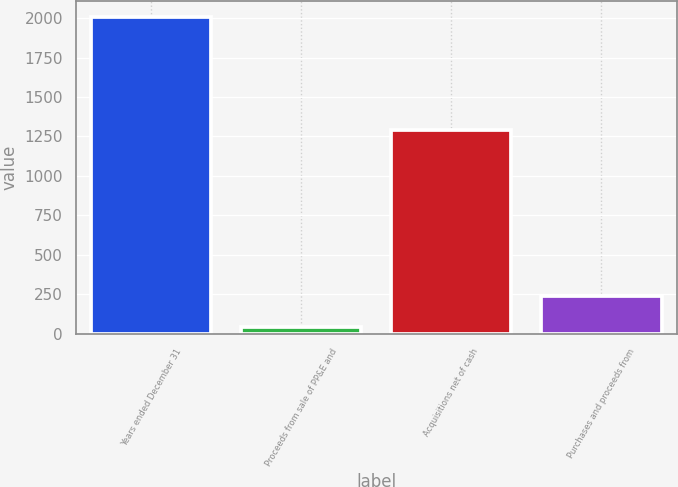Convert chart to OTSL. <chart><loc_0><loc_0><loc_500><loc_500><bar_chart><fcel>Years ended December 31<fcel>Proceeds from sale of PP&E and<fcel>Acquisitions net of cash<fcel>Purchases and proceeds from<nl><fcel>2005<fcel>41<fcel>1293<fcel>237.4<nl></chart> 